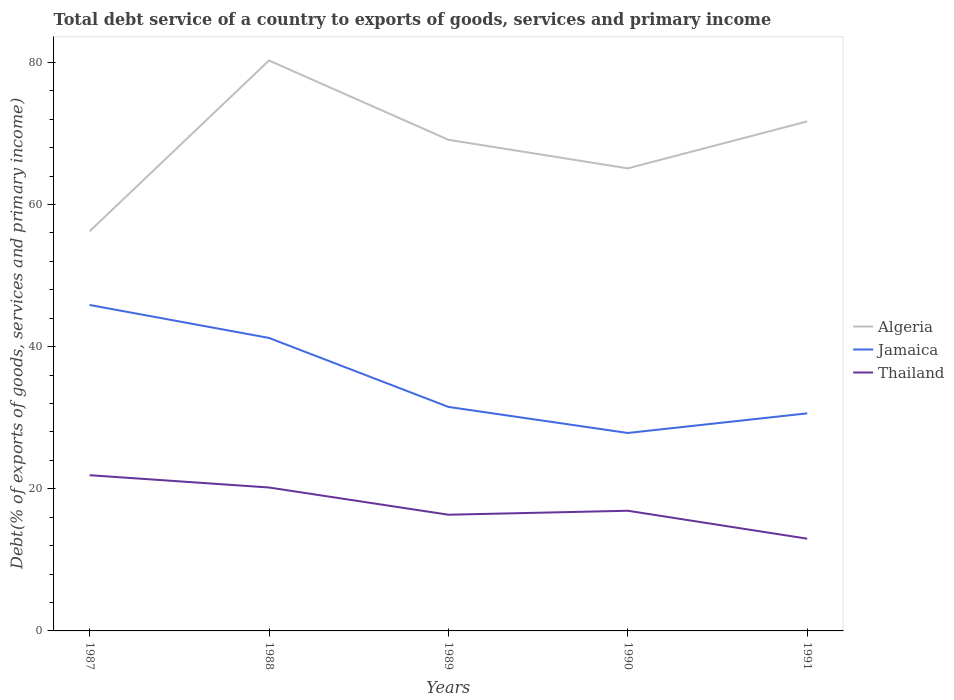How many different coloured lines are there?
Provide a succinct answer. 3. Does the line corresponding to Thailand intersect with the line corresponding to Jamaica?
Keep it short and to the point. No. Is the number of lines equal to the number of legend labels?
Your response must be concise. Yes. Across all years, what is the maximum total debt service in Algeria?
Make the answer very short. 56.22. In which year was the total debt service in Algeria maximum?
Your answer should be compact. 1987. What is the total total debt service in Jamaica in the graph?
Offer a terse response. 10.61. What is the difference between the highest and the second highest total debt service in Jamaica?
Provide a succinct answer. 18.01. How many lines are there?
Your response must be concise. 3. How many years are there in the graph?
Make the answer very short. 5. Does the graph contain grids?
Your answer should be compact. No. Where does the legend appear in the graph?
Your response must be concise. Center right. What is the title of the graph?
Give a very brief answer. Total debt service of a country to exports of goods, services and primary income. What is the label or title of the X-axis?
Your answer should be compact. Years. What is the label or title of the Y-axis?
Your answer should be compact. Debt(% of exports of goods, services and primary income). What is the Debt(% of exports of goods, services and primary income) of Algeria in 1987?
Ensure brevity in your answer.  56.22. What is the Debt(% of exports of goods, services and primary income) of Jamaica in 1987?
Ensure brevity in your answer.  45.86. What is the Debt(% of exports of goods, services and primary income) in Thailand in 1987?
Your answer should be compact. 21.91. What is the Debt(% of exports of goods, services and primary income) of Algeria in 1988?
Your response must be concise. 80.26. What is the Debt(% of exports of goods, services and primary income) in Jamaica in 1988?
Provide a succinct answer. 41.22. What is the Debt(% of exports of goods, services and primary income) of Thailand in 1988?
Your response must be concise. 20.18. What is the Debt(% of exports of goods, services and primary income) in Algeria in 1989?
Give a very brief answer. 69.1. What is the Debt(% of exports of goods, services and primary income) in Jamaica in 1989?
Your response must be concise. 31.52. What is the Debt(% of exports of goods, services and primary income) in Thailand in 1989?
Your response must be concise. 16.35. What is the Debt(% of exports of goods, services and primary income) in Algeria in 1990?
Offer a terse response. 65.08. What is the Debt(% of exports of goods, services and primary income) of Jamaica in 1990?
Give a very brief answer. 27.85. What is the Debt(% of exports of goods, services and primary income) of Thailand in 1990?
Ensure brevity in your answer.  16.91. What is the Debt(% of exports of goods, services and primary income) of Algeria in 1991?
Give a very brief answer. 71.69. What is the Debt(% of exports of goods, services and primary income) of Jamaica in 1991?
Provide a short and direct response. 30.61. What is the Debt(% of exports of goods, services and primary income) of Thailand in 1991?
Your answer should be very brief. 12.98. Across all years, what is the maximum Debt(% of exports of goods, services and primary income) of Algeria?
Provide a succinct answer. 80.26. Across all years, what is the maximum Debt(% of exports of goods, services and primary income) of Jamaica?
Ensure brevity in your answer.  45.86. Across all years, what is the maximum Debt(% of exports of goods, services and primary income) in Thailand?
Give a very brief answer. 21.91. Across all years, what is the minimum Debt(% of exports of goods, services and primary income) of Algeria?
Make the answer very short. 56.22. Across all years, what is the minimum Debt(% of exports of goods, services and primary income) in Jamaica?
Provide a succinct answer. 27.85. Across all years, what is the minimum Debt(% of exports of goods, services and primary income) in Thailand?
Make the answer very short. 12.98. What is the total Debt(% of exports of goods, services and primary income) of Algeria in the graph?
Your answer should be compact. 342.36. What is the total Debt(% of exports of goods, services and primary income) of Jamaica in the graph?
Keep it short and to the point. 177.06. What is the total Debt(% of exports of goods, services and primary income) in Thailand in the graph?
Offer a terse response. 88.32. What is the difference between the Debt(% of exports of goods, services and primary income) of Algeria in 1987 and that in 1988?
Your answer should be very brief. -24.04. What is the difference between the Debt(% of exports of goods, services and primary income) of Jamaica in 1987 and that in 1988?
Offer a very short reply. 4.64. What is the difference between the Debt(% of exports of goods, services and primary income) of Thailand in 1987 and that in 1988?
Your response must be concise. 1.73. What is the difference between the Debt(% of exports of goods, services and primary income) of Algeria in 1987 and that in 1989?
Offer a very short reply. -12.88. What is the difference between the Debt(% of exports of goods, services and primary income) in Jamaica in 1987 and that in 1989?
Provide a succinct answer. 14.34. What is the difference between the Debt(% of exports of goods, services and primary income) of Thailand in 1987 and that in 1989?
Provide a succinct answer. 5.56. What is the difference between the Debt(% of exports of goods, services and primary income) of Algeria in 1987 and that in 1990?
Ensure brevity in your answer.  -8.86. What is the difference between the Debt(% of exports of goods, services and primary income) in Jamaica in 1987 and that in 1990?
Your response must be concise. 18.01. What is the difference between the Debt(% of exports of goods, services and primary income) in Thailand in 1987 and that in 1990?
Give a very brief answer. 5. What is the difference between the Debt(% of exports of goods, services and primary income) of Algeria in 1987 and that in 1991?
Offer a very short reply. -15.47. What is the difference between the Debt(% of exports of goods, services and primary income) in Jamaica in 1987 and that in 1991?
Your answer should be compact. 15.25. What is the difference between the Debt(% of exports of goods, services and primary income) of Thailand in 1987 and that in 1991?
Your answer should be compact. 8.93. What is the difference between the Debt(% of exports of goods, services and primary income) in Algeria in 1988 and that in 1989?
Your answer should be compact. 11.16. What is the difference between the Debt(% of exports of goods, services and primary income) in Jamaica in 1988 and that in 1989?
Keep it short and to the point. 9.7. What is the difference between the Debt(% of exports of goods, services and primary income) of Thailand in 1988 and that in 1989?
Offer a very short reply. 3.83. What is the difference between the Debt(% of exports of goods, services and primary income) of Algeria in 1988 and that in 1990?
Your answer should be very brief. 15.18. What is the difference between the Debt(% of exports of goods, services and primary income) in Jamaica in 1988 and that in 1990?
Provide a short and direct response. 13.37. What is the difference between the Debt(% of exports of goods, services and primary income) of Thailand in 1988 and that in 1990?
Keep it short and to the point. 3.27. What is the difference between the Debt(% of exports of goods, services and primary income) in Algeria in 1988 and that in 1991?
Offer a very short reply. 8.57. What is the difference between the Debt(% of exports of goods, services and primary income) in Jamaica in 1988 and that in 1991?
Keep it short and to the point. 10.61. What is the difference between the Debt(% of exports of goods, services and primary income) in Thailand in 1988 and that in 1991?
Make the answer very short. 7.2. What is the difference between the Debt(% of exports of goods, services and primary income) of Algeria in 1989 and that in 1990?
Offer a terse response. 4.02. What is the difference between the Debt(% of exports of goods, services and primary income) in Jamaica in 1989 and that in 1990?
Provide a short and direct response. 3.67. What is the difference between the Debt(% of exports of goods, services and primary income) in Thailand in 1989 and that in 1990?
Give a very brief answer. -0.56. What is the difference between the Debt(% of exports of goods, services and primary income) of Algeria in 1989 and that in 1991?
Provide a short and direct response. -2.59. What is the difference between the Debt(% of exports of goods, services and primary income) in Jamaica in 1989 and that in 1991?
Make the answer very short. 0.91. What is the difference between the Debt(% of exports of goods, services and primary income) of Thailand in 1989 and that in 1991?
Give a very brief answer. 3.37. What is the difference between the Debt(% of exports of goods, services and primary income) in Algeria in 1990 and that in 1991?
Offer a terse response. -6.61. What is the difference between the Debt(% of exports of goods, services and primary income) in Jamaica in 1990 and that in 1991?
Your answer should be compact. -2.76. What is the difference between the Debt(% of exports of goods, services and primary income) of Thailand in 1990 and that in 1991?
Provide a succinct answer. 3.93. What is the difference between the Debt(% of exports of goods, services and primary income) of Algeria in 1987 and the Debt(% of exports of goods, services and primary income) of Jamaica in 1988?
Provide a short and direct response. 15. What is the difference between the Debt(% of exports of goods, services and primary income) in Algeria in 1987 and the Debt(% of exports of goods, services and primary income) in Thailand in 1988?
Keep it short and to the point. 36.04. What is the difference between the Debt(% of exports of goods, services and primary income) of Jamaica in 1987 and the Debt(% of exports of goods, services and primary income) of Thailand in 1988?
Your answer should be very brief. 25.68. What is the difference between the Debt(% of exports of goods, services and primary income) in Algeria in 1987 and the Debt(% of exports of goods, services and primary income) in Jamaica in 1989?
Provide a succinct answer. 24.7. What is the difference between the Debt(% of exports of goods, services and primary income) in Algeria in 1987 and the Debt(% of exports of goods, services and primary income) in Thailand in 1989?
Give a very brief answer. 39.87. What is the difference between the Debt(% of exports of goods, services and primary income) in Jamaica in 1987 and the Debt(% of exports of goods, services and primary income) in Thailand in 1989?
Provide a short and direct response. 29.51. What is the difference between the Debt(% of exports of goods, services and primary income) of Algeria in 1987 and the Debt(% of exports of goods, services and primary income) of Jamaica in 1990?
Keep it short and to the point. 28.37. What is the difference between the Debt(% of exports of goods, services and primary income) of Algeria in 1987 and the Debt(% of exports of goods, services and primary income) of Thailand in 1990?
Provide a short and direct response. 39.31. What is the difference between the Debt(% of exports of goods, services and primary income) in Jamaica in 1987 and the Debt(% of exports of goods, services and primary income) in Thailand in 1990?
Your response must be concise. 28.95. What is the difference between the Debt(% of exports of goods, services and primary income) of Algeria in 1987 and the Debt(% of exports of goods, services and primary income) of Jamaica in 1991?
Provide a succinct answer. 25.61. What is the difference between the Debt(% of exports of goods, services and primary income) in Algeria in 1987 and the Debt(% of exports of goods, services and primary income) in Thailand in 1991?
Offer a very short reply. 43.25. What is the difference between the Debt(% of exports of goods, services and primary income) in Jamaica in 1987 and the Debt(% of exports of goods, services and primary income) in Thailand in 1991?
Give a very brief answer. 32.88. What is the difference between the Debt(% of exports of goods, services and primary income) of Algeria in 1988 and the Debt(% of exports of goods, services and primary income) of Jamaica in 1989?
Your answer should be compact. 48.74. What is the difference between the Debt(% of exports of goods, services and primary income) of Algeria in 1988 and the Debt(% of exports of goods, services and primary income) of Thailand in 1989?
Keep it short and to the point. 63.91. What is the difference between the Debt(% of exports of goods, services and primary income) in Jamaica in 1988 and the Debt(% of exports of goods, services and primary income) in Thailand in 1989?
Provide a short and direct response. 24.87. What is the difference between the Debt(% of exports of goods, services and primary income) of Algeria in 1988 and the Debt(% of exports of goods, services and primary income) of Jamaica in 1990?
Keep it short and to the point. 52.41. What is the difference between the Debt(% of exports of goods, services and primary income) of Algeria in 1988 and the Debt(% of exports of goods, services and primary income) of Thailand in 1990?
Provide a short and direct response. 63.35. What is the difference between the Debt(% of exports of goods, services and primary income) in Jamaica in 1988 and the Debt(% of exports of goods, services and primary income) in Thailand in 1990?
Make the answer very short. 24.31. What is the difference between the Debt(% of exports of goods, services and primary income) in Algeria in 1988 and the Debt(% of exports of goods, services and primary income) in Jamaica in 1991?
Make the answer very short. 49.65. What is the difference between the Debt(% of exports of goods, services and primary income) in Algeria in 1988 and the Debt(% of exports of goods, services and primary income) in Thailand in 1991?
Your answer should be compact. 67.28. What is the difference between the Debt(% of exports of goods, services and primary income) in Jamaica in 1988 and the Debt(% of exports of goods, services and primary income) in Thailand in 1991?
Your response must be concise. 28.25. What is the difference between the Debt(% of exports of goods, services and primary income) in Algeria in 1989 and the Debt(% of exports of goods, services and primary income) in Jamaica in 1990?
Provide a succinct answer. 41.25. What is the difference between the Debt(% of exports of goods, services and primary income) of Algeria in 1989 and the Debt(% of exports of goods, services and primary income) of Thailand in 1990?
Offer a very short reply. 52.2. What is the difference between the Debt(% of exports of goods, services and primary income) of Jamaica in 1989 and the Debt(% of exports of goods, services and primary income) of Thailand in 1990?
Make the answer very short. 14.61. What is the difference between the Debt(% of exports of goods, services and primary income) of Algeria in 1989 and the Debt(% of exports of goods, services and primary income) of Jamaica in 1991?
Offer a terse response. 38.49. What is the difference between the Debt(% of exports of goods, services and primary income) in Algeria in 1989 and the Debt(% of exports of goods, services and primary income) in Thailand in 1991?
Ensure brevity in your answer.  56.13. What is the difference between the Debt(% of exports of goods, services and primary income) in Jamaica in 1989 and the Debt(% of exports of goods, services and primary income) in Thailand in 1991?
Offer a very short reply. 18.54. What is the difference between the Debt(% of exports of goods, services and primary income) of Algeria in 1990 and the Debt(% of exports of goods, services and primary income) of Jamaica in 1991?
Provide a succinct answer. 34.47. What is the difference between the Debt(% of exports of goods, services and primary income) in Algeria in 1990 and the Debt(% of exports of goods, services and primary income) in Thailand in 1991?
Make the answer very short. 52.1. What is the difference between the Debt(% of exports of goods, services and primary income) of Jamaica in 1990 and the Debt(% of exports of goods, services and primary income) of Thailand in 1991?
Ensure brevity in your answer.  14.87. What is the average Debt(% of exports of goods, services and primary income) of Algeria per year?
Offer a terse response. 68.47. What is the average Debt(% of exports of goods, services and primary income) in Jamaica per year?
Your answer should be very brief. 35.41. What is the average Debt(% of exports of goods, services and primary income) in Thailand per year?
Your answer should be compact. 17.66. In the year 1987, what is the difference between the Debt(% of exports of goods, services and primary income) of Algeria and Debt(% of exports of goods, services and primary income) of Jamaica?
Provide a succinct answer. 10.36. In the year 1987, what is the difference between the Debt(% of exports of goods, services and primary income) of Algeria and Debt(% of exports of goods, services and primary income) of Thailand?
Give a very brief answer. 34.31. In the year 1987, what is the difference between the Debt(% of exports of goods, services and primary income) of Jamaica and Debt(% of exports of goods, services and primary income) of Thailand?
Offer a terse response. 23.95. In the year 1988, what is the difference between the Debt(% of exports of goods, services and primary income) of Algeria and Debt(% of exports of goods, services and primary income) of Jamaica?
Your answer should be compact. 39.04. In the year 1988, what is the difference between the Debt(% of exports of goods, services and primary income) of Algeria and Debt(% of exports of goods, services and primary income) of Thailand?
Keep it short and to the point. 60.08. In the year 1988, what is the difference between the Debt(% of exports of goods, services and primary income) of Jamaica and Debt(% of exports of goods, services and primary income) of Thailand?
Provide a short and direct response. 21.04. In the year 1989, what is the difference between the Debt(% of exports of goods, services and primary income) of Algeria and Debt(% of exports of goods, services and primary income) of Jamaica?
Make the answer very short. 37.59. In the year 1989, what is the difference between the Debt(% of exports of goods, services and primary income) in Algeria and Debt(% of exports of goods, services and primary income) in Thailand?
Offer a very short reply. 52.75. In the year 1989, what is the difference between the Debt(% of exports of goods, services and primary income) of Jamaica and Debt(% of exports of goods, services and primary income) of Thailand?
Keep it short and to the point. 15.17. In the year 1990, what is the difference between the Debt(% of exports of goods, services and primary income) in Algeria and Debt(% of exports of goods, services and primary income) in Jamaica?
Provide a short and direct response. 37.23. In the year 1990, what is the difference between the Debt(% of exports of goods, services and primary income) of Algeria and Debt(% of exports of goods, services and primary income) of Thailand?
Offer a very short reply. 48.17. In the year 1990, what is the difference between the Debt(% of exports of goods, services and primary income) in Jamaica and Debt(% of exports of goods, services and primary income) in Thailand?
Your response must be concise. 10.94. In the year 1991, what is the difference between the Debt(% of exports of goods, services and primary income) of Algeria and Debt(% of exports of goods, services and primary income) of Jamaica?
Ensure brevity in your answer.  41.08. In the year 1991, what is the difference between the Debt(% of exports of goods, services and primary income) of Algeria and Debt(% of exports of goods, services and primary income) of Thailand?
Offer a very short reply. 58.71. In the year 1991, what is the difference between the Debt(% of exports of goods, services and primary income) of Jamaica and Debt(% of exports of goods, services and primary income) of Thailand?
Provide a succinct answer. 17.63. What is the ratio of the Debt(% of exports of goods, services and primary income) in Algeria in 1987 to that in 1988?
Offer a very short reply. 0.7. What is the ratio of the Debt(% of exports of goods, services and primary income) in Jamaica in 1987 to that in 1988?
Provide a short and direct response. 1.11. What is the ratio of the Debt(% of exports of goods, services and primary income) of Thailand in 1987 to that in 1988?
Your answer should be very brief. 1.09. What is the ratio of the Debt(% of exports of goods, services and primary income) of Algeria in 1987 to that in 1989?
Your answer should be compact. 0.81. What is the ratio of the Debt(% of exports of goods, services and primary income) of Jamaica in 1987 to that in 1989?
Offer a very short reply. 1.46. What is the ratio of the Debt(% of exports of goods, services and primary income) of Thailand in 1987 to that in 1989?
Your answer should be compact. 1.34. What is the ratio of the Debt(% of exports of goods, services and primary income) of Algeria in 1987 to that in 1990?
Give a very brief answer. 0.86. What is the ratio of the Debt(% of exports of goods, services and primary income) of Jamaica in 1987 to that in 1990?
Your answer should be very brief. 1.65. What is the ratio of the Debt(% of exports of goods, services and primary income) of Thailand in 1987 to that in 1990?
Provide a succinct answer. 1.3. What is the ratio of the Debt(% of exports of goods, services and primary income) of Algeria in 1987 to that in 1991?
Your response must be concise. 0.78. What is the ratio of the Debt(% of exports of goods, services and primary income) of Jamaica in 1987 to that in 1991?
Give a very brief answer. 1.5. What is the ratio of the Debt(% of exports of goods, services and primary income) in Thailand in 1987 to that in 1991?
Make the answer very short. 1.69. What is the ratio of the Debt(% of exports of goods, services and primary income) of Algeria in 1988 to that in 1989?
Give a very brief answer. 1.16. What is the ratio of the Debt(% of exports of goods, services and primary income) in Jamaica in 1988 to that in 1989?
Your response must be concise. 1.31. What is the ratio of the Debt(% of exports of goods, services and primary income) in Thailand in 1988 to that in 1989?
Offer a very short reply. 1.23. What is the ratio of the Debt(% of exports of goods, services and primary income) of Algeria in 1988 to that in 1990?
Provide a short and direct response. 1.23. What is the ratio of the Debt(% of exports of goods, services and primary income) of Jamaica in 1988 to that in 1990?
Ensure brevity in your answer.  1.48. What is the ratio of the Debt(% of exports of goods, services and primary income) in Thailand in 1988 to that in 1990?
Your answer should be very brief. 1.19. What is the ratio of the Debt(% of exports of goods, services and primary income) in Algeria in 1988 to that in 1991?
Give a very brief answer. 1.12. What is the ratio of the Debt(% of exports of goods, services and primary income) in Jamaica in 1988 to that in 1991?
Provide a short and direct response. 1.35. What is the ratio of the Debt(% of exports of goods, services and primary income) in Thailand in 1988 to that in 1991?
Your answer should be very brief. 1.55. What is the ratio of the Debt(% of exports of goods, services and primary income) of Algeria in 1989 to that in 1990?
Provide a succinct answer. 1.06. What is the ratio of the Debt(% of exports of goods, services and primary income) in Jamaica in 1989 to that in 1990?
Make the answer very short. 1.13. What is the ratio of the Debt(% of exports of goods, services and primary income) in Thailand in 1989 to that in 1990?
Give a very brief answer. 0.97. What is the ratio of the Debt(% of exports of goods, services and primary income) in Algeria in 1989 to that in 1991?
Ensure brevity in your answer.  0.96. What is the ratio of the Debt(% of exports of goods, services and primary income) in Jamaica in 1989 to that in 1991?
Provide a short and direct response. 1.03. What is the ratio of the Debt(% of exports of goods, services and primary income) of Thailand in 1989 to that in 1991?
Your answer should be very brief. 1.26. What is the ratio of the Debt(% of exports of goods, services and primary income) in Algeria in 1990 to that in 1991?
Your answer should be very brief. 0.91. What is the ratio of the Debt(% of exports of goods, services and primary income) in Jamaica in 1990 to that in 1991?
Keep it short and to the point. 0.91. What is the ratio of the Debt(% of exports of goods, services and primary income) of Thailand in 1990 to that in 1991?
Your answer should be very brief. 1.3. What is the difference between the highest and the second highest Debt(% of exports of goods, services and primary income) in Algeria?
Offer a terse response. 8.57. What is the difference between the highest and the second highest Debt(% of exports of goods, services and primary income) in Jamaica?
Provide a succinct answer. 4.64. What is the difference between the highest and the second highest Debt(% of exports of goods, services and primary income) of Thailand?
Your answer should be compact. 1.73. What is the difference between the highest and the lowest Debt(% of exports of goods, services and primary income) in Algeria?
Provide a short and direct response. 24.04. What is the difference between the highest and the lowest Debt(% of exports of goods, services and primary income) in Jamaica?
Make the answer very short. 18.01. What is the difference between the highest and the lowest Debt(% of exports of goods, services and primary income) of Thailand?
Give a very brief answer. 8.93. 